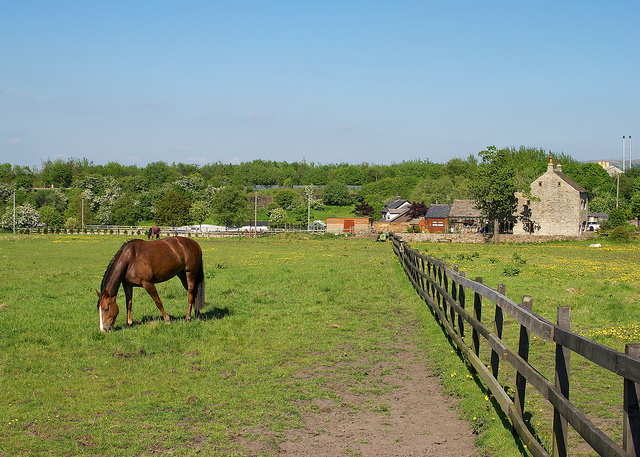What types of plants can be seen in the horse's grazing area? In the grazing area, you can notice a variety of grasses and wildflowers, which are typical in open pastures. These plants provide a natural diet for the horse, helping in its digestive regulation and overall health. The presence of diverse vegetation can also benefit the soil quality and contribute to the ecological balance of the area. 